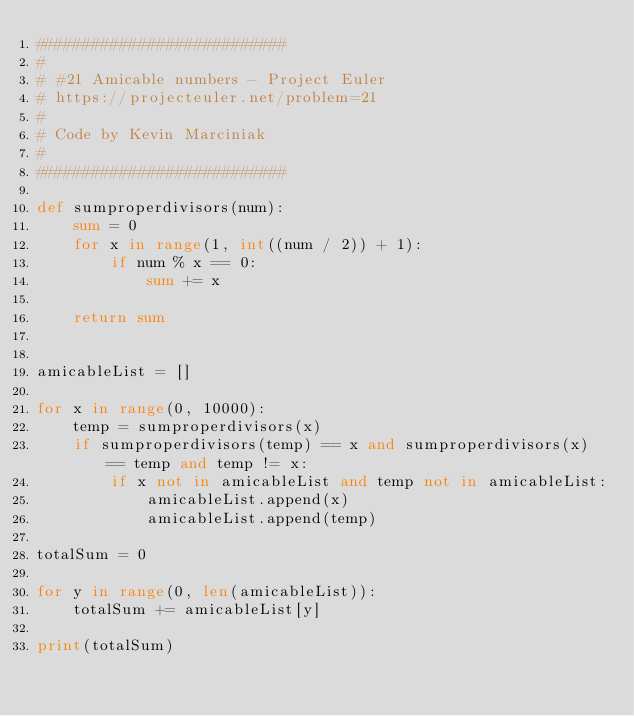<code> <loc_0><loc_0><loc_500><loc_500><_Python_>###########################
#
# #21 Amicable numbers - Project Euler
# https://projecteuler.net/problem=21
#
# Code by Kevin Marciniak
#
###########################

def sumproperdivisors(num):
    sum = 0
    for x in range(1, int((num / 2)) + 1):
        if num % x == 0:
            sum += x

    return sum


amicableList = []

for x in range(0, 10000):
    temp = sumproperdivisors(x)
    if sumproperdivisors(temp) == x and sumproperdivisors(x) == temp and temp != x:
        if x not in amicableList and temp not in amicableList:
            amicableList.append(x)
            amicableList.append(temp)

totalSum = 0

for y in range(0, len(amicableList)):
    totalSum += amicableList[y]

print(totalSum)
</code> 